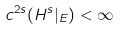<formula> <loc_0><loc_0><loc_500><loc_500>c ^ { 2 s } ( H ^ { s } | _ { E } ) < \infty</formula> 